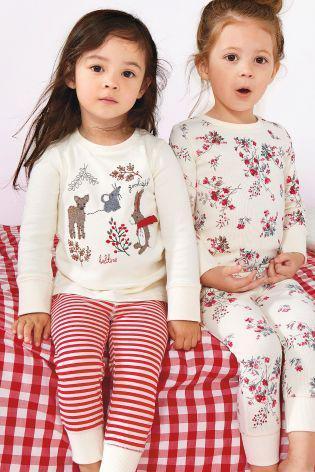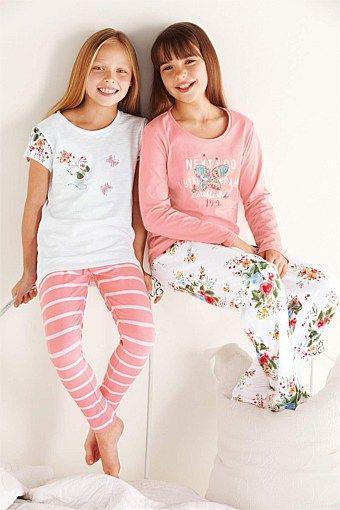The first image is the image on the left, the second image is the image on the right. Evaluate the accuracy of this statement regarding the images: "There are two children walking on a bed in one image.". Is it true? Answer yes or no. No. The first image is the image on the left, the second image is the image on the right. Evaluate the accuracy of this statement regarding the images: "In the left image, the kids are holding each other's hands.". Is it true? Answer yes or no. No. 